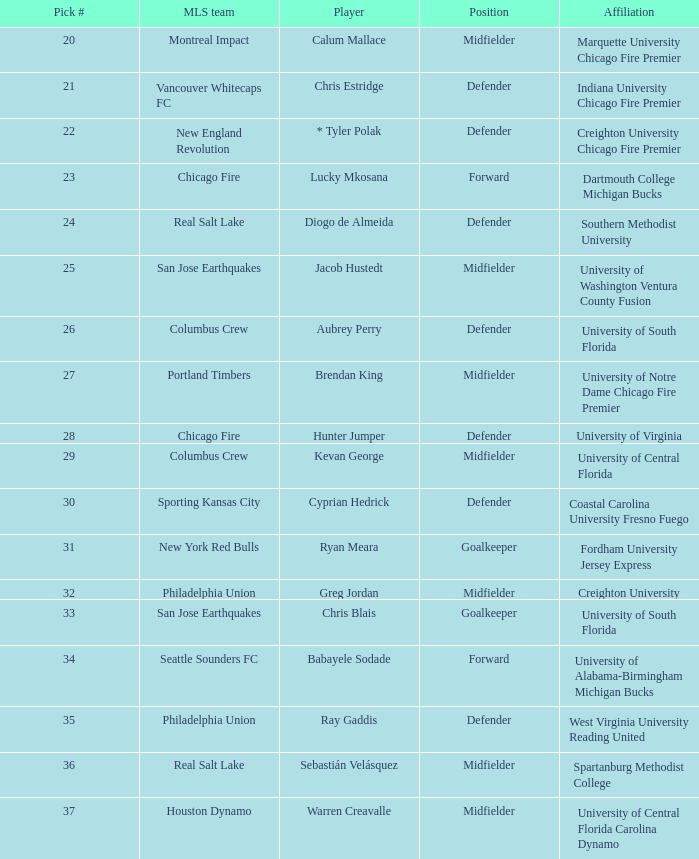Which mls team selected babayele sodade? Seattle Sounders FC. 